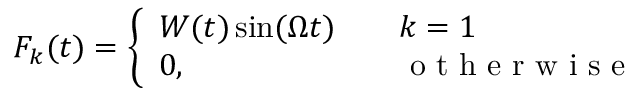Convert formula to latex. <formula><loc_0><loc_0><loc_500><loc_500>{ F } _ { k } ( t ) = \left \{ \begin{array} { l l } { W ( t ) \sin ( \Omega t ) \quad } & { k = 1 } \\ { 0 , \quad } & { o t h e r w i s e } \end{array}</formula> 